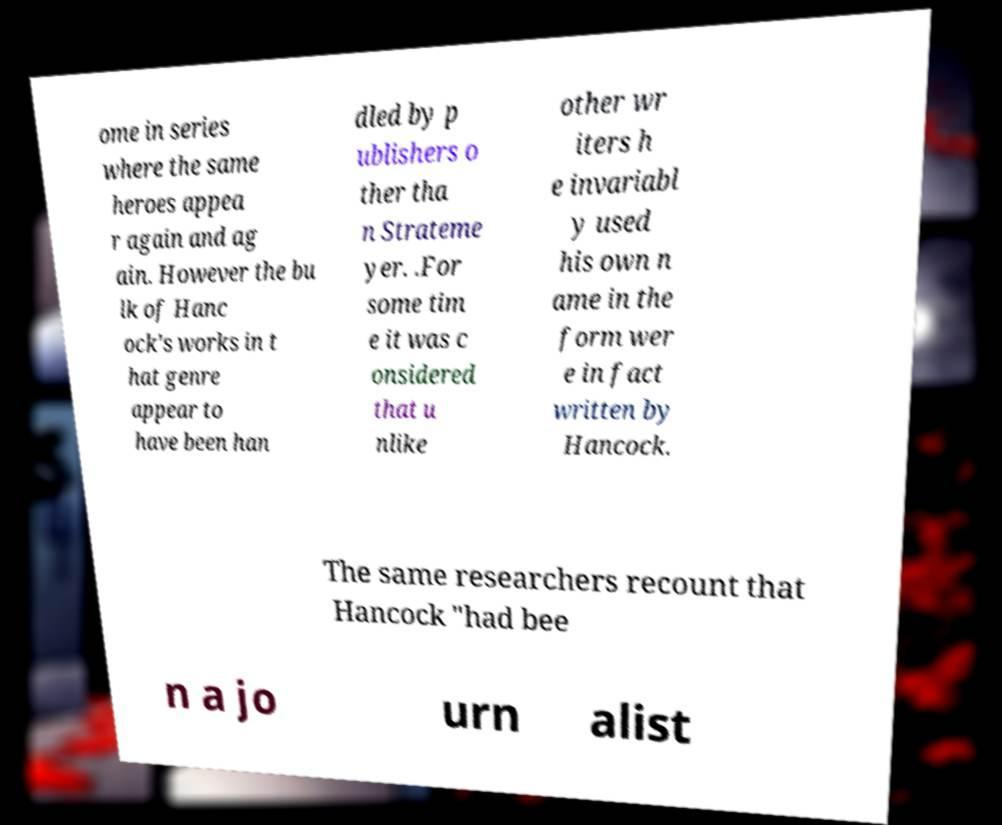I need the written content from this picture converted into text. Can you do that? ome in series where the same heroes appea r again and ag ain. However the bu lk of Hanc ock's works in t hat genre appear to have been han dled by p ublishers o ther tha n Strateme yer. .For some tim e it was c onsidered that u nlike other wr iters h e invariabl y used his own n ame in the form wer e in fact written by Hancock. The same researchers recount that Hancock "had bee n a jo urn alist 